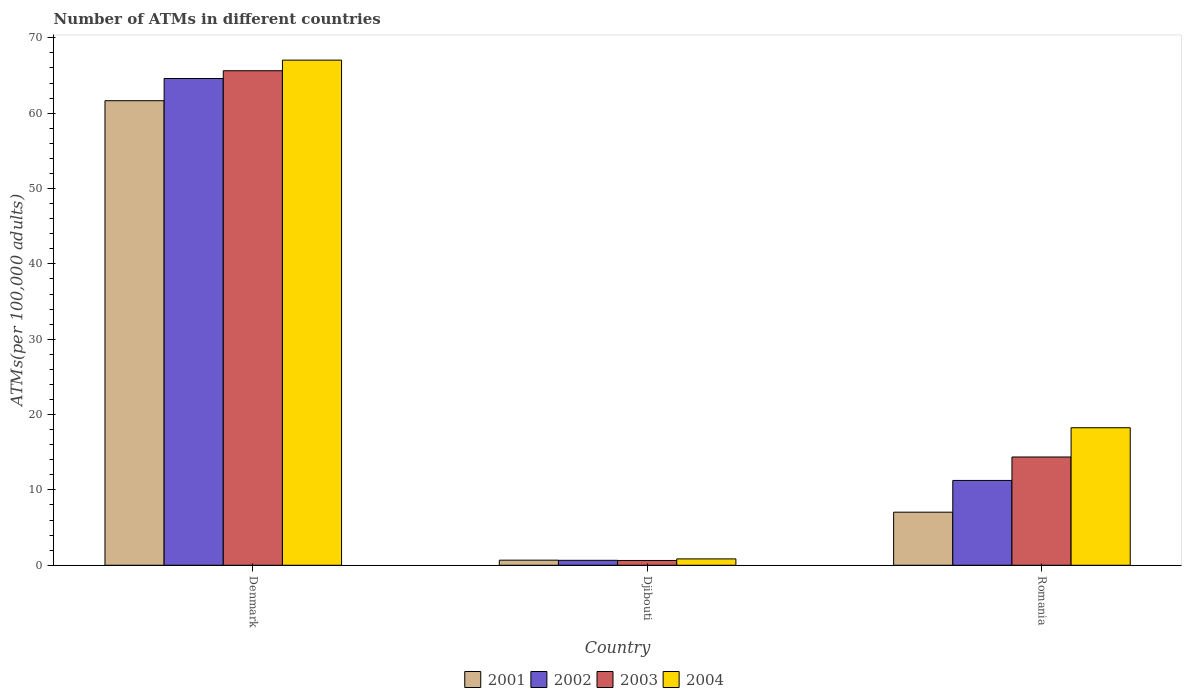How many different coloured bars are there?
Make the answer very short. 4. How many groups of bars are there?
Ensure brevity in your answer.  3. Are the number of bars on each tick of the X-axis equal?
Ensure brevity in your answer.  Yes. How many bars are there on the 2nd tick from the left?
Make the answer very short. 4. How many bars are there on the 1st tick from the right?
Ensure brevity in your answer.  4. What is the label of the 2nd group of bars from the left?
Your answer should be compact. Djibouti. In how many cases, is the number of bars for a given country not equal to the number of legend labels?
Give a very brief answer. 0. What is the number of ATMs in 2001 in Djibouti?
Provide a short and direct response. 0.68. Across all countries, what is the maximum number of ATMs in 2001?
Ensure brevity in your answer.  61.66. Across all countries, what is the minimum number of ATMs in 2002?
Keep it short and to the point. 0.66. In which country was the number of ATMs in 2004 maximum?
Your answer should be compact. Denmark. In which country was the number of ATMs in 2002 minimum?
Your answer should be very brief. Djibouti. What is the total number of ATMs in 2004 in the graph?
Ensure brevity in your answer.  86.14. What is the difference between the number of ATMs in 2002 in Denmark and that in Romania?
Keep it short and to the point. 53.35. What is the difference between the number of ATMs in 2001 in Romania and the number of ATMs in 2003 in Djibouti?
Ensure brevity in your answer.  6.41. What is the average number of ATMs in 2004 per country?
Make the answer very short. 28.71. What is the difference between the number of ATMs of/in 2002 and number of ATMs of/in 2004 in Djibouti?
Make the answer very short. -0.19. In how many countries, is the number of ATMs in 2002 greater than 46?
Keep it short and to the point. 1. What is the ratio of the number of ATMs in 2004 in Djibouti to that in Romania?
Your response must be concise. 0.05. What is the difference between the highest and the second highest number of ATMs in 2003?
Provide a succinct answer. -65. What is the difference between the highest and the lowest number of ATMs in 2003?
Your response must be concise. 65. Is the sum of the number of ATMs in 2003 in Djibouti and Romania greater than the maximum number of ATMs in 2001 across all countries?
Give a very brief answer. No. What does the 1st bar from the left in Denmark represents?
Your answer should be very brief. 2001. How many bars are there?
Provide a short and direct response. 12. How many countries are there in the graph?
Provide a succinct answer. 3. What is the difference between two consecutive major ticks on the Y-axis?
Offer a very short reply. 10. Does the graph contain any zero values?
Provide a succinct answer. No. How many legend labels are there?
Your answer should be compact. 4. How are the legend labels stacked?
Provide a short and direct response. Horizontal. What is the title of the graph?
Your response must be concise. Number of ATMs in different countries. What is the label or title of the X-axis?
Offer a terse response. Country. What is the label or title of the Y-axis?
Offer a terse response. ATMs(per 100,0 adults). What is the ATMs(per 100,000 adults) of 2001 in Denmark?
Provide a short and direct response. 61.66. What is the ATMs(per 100,000 adults) of 2002 in Denmark?
Offer a very short reply. 64.61. What is the ATMs(per 100,000 adults) in 2003 in Denmark?
Give a very brief answer. 65.64. What is the ATMs(per 100,000 adults) of 2004 in Denmark?
Offer a very short reply. 67.04. What is the ATMs(per 100,000 adults) of 2001 in Djibouti?
Provide a short and direct response. 0.68. What is the ATMs(per 100,000 adults) in 2002 in Djibouti?
Make the answer very short. 0.66. What is the ATMs(per 100,000 adults) of 2003 in Djibouti?
Give a very brief answer. 0.64. What is the ATMs(per 100,000 adults) of 2004 in Djibouti?
Your response must be concise. 0.84. What is the ATMs(per 100,000 adults) of 2001 in Romania?
Provide a succinct answer. 7.04. What is the ATMs(per 100,000 adults) in 2002 in Romania?
Keep it short and to the point. 11.26. What is the ATMs(per 100,000 adults) in 2003 in Romania?
Offer a very short reply. 14.37. What is the ATMs(per 100,000 adults) in 2004 in Romania?
Your answer should be very brief. 18.26. Across all countries, what is the maximum ATMs(per 100,000 adults) of 2001?
Offer a terse response. 61.66. Across all countries, what is the maximum ATMs(per 100,000 adults) of 2002?
Give a very brief answer. 64.61. Across all countries, what is the maximum ATMs(per 100,000 adults) in 2003?
Provide a succinct answer. 65.64. Across all countries, what is the maximum ATMs(per 100,000 adults) of 2004?
Ensure brevity in your answer.  67.04. Across all countries, what is the minimum ATMs(per 100,000 adults) in 2001?
Provide a succinct answer. 0.68. Across all countries, what is the minimum ATMs(per 100,000 adults) of 2002?
Provide a succinct answer. 0.66. Across all countries, what is the minimum ATMs(per 100,000 adults) in 2003?
Offer a very short reply. 0.64. Across all countries, what is the minimum ATMs(per 100,000 adults) in 2004?
Offer a very short reply. 0.84. What is the total ATMs(per 100,000 adults) in 2001 in the graph?
Keep it short and to the point. 69.38. What is the total ATMs(per 100,000 adults) in 2002 in the graph?
Your response must be concise. 76.52. What is the total ATMs(per 100,000 adults) in 2003 in the graph?
Offer a terse response. 80.65. What is the total ATMs(per 100,000 adults) of 2004 in the graph?
Your response must be concise. 86.14. What is the difference between the ATMs(per 100,000 adults) of 2001 in Denmark and that in Djibouti?
Your answer should be compact. 60.98. What is the difference between the ATMs(per 100,000 adults) of 2002 in Denmark and that in Djibouti?
Offer a terse response. 63.95. What is the difference between the ATMs(per 100,000 adults) in 2003 in Denmark and that in Djibouti?
Give a very brief answer. 65. What is the difference between the ATMs(per 100,000 adults) in 2004 in Denmark and that in Djibouti?
Provide a short and direct response. 66.2. What is the difference between the ATMs(per 100,000 adults) in 2001 in Denmark and that in Romania?
Provide a succinct answer. 54.61. What is the difference between the ATMs(per 100,000 adults) of 2002 in Denmark and that in Romania?
Ensure brevity in your answer.  53.35. What is the difference between the ATMs(per 100,000 adults) of 2003 in Denmark and that in Romania?
Offer a very short reply. 51.27. What is the difference between the ATMs(per 100,000 adults) in 2004 in Denmark and that in Romania?
Your answer should be very brief. 48.79. What is the difference between the ATMs(per 100,000 adults) of 2001 in Djibouti and that in Romania?
Ensure brevity in your answer.  -6.37. What is the difference between the ATMs(per 100,000 adults) in 2002 in Djibouti and that in Romania?
Provide a succinct answer. -10.6. What is the difference between the ATMs(per 100,000 adults) of 2003 in Djibouti and that in Romania?
Provide a succinct answer. -13.73. What is the difference between the ATMs(per 100,000 adults) in 2004 in Djibouti and that in Romania?
Offer a terse response. -17.41. What is the difference between the ATMs(per 100,000 adults) in 2001 in Denmark and the ATMs(per 100,000 adults) in 2002 in Djibouti?
Your answer should be compact. 61. What is the difference between the ATMs(per 100,000 adults) of 2001 in Denmark and the ATMs(per 100,000 adults) of 2003 in Djibouti?
Keep it short and to the point. 61.02. What is the difference between the ATMs(per 100,000 adults) of 2001 in Denmark and the ATMs(per 100,000 adults) of 2004 in Djibouti?
Ensure brevity in your answer.  60.81. What is the difference between the ATMs(per 100,000 adults) of 2002 in Denmark and the ATMs(per 100,000 adults) of 2003 in Djibouti?
Keep it short and to the point. 63.97. What is the difference between the ATMs(per 100,000 adults) in 2002 in Denmark and the ATMs(per 100,000 adults) in 2004 in Djibouti?
Give a very brief answer. 63.76. What is the difference between the ATMs(per 100,000 adults) of 2003 in Denmark and the ATMs(per 100,000 adults) of 2004 in Djibouti?
Your answer should be very brief. 64.79. What is the difference between the ATMs(per 100,000 adults) of 2001 in Denmark and the ATMs(per 100,000 adults) of 2002 in Romania?
Make the answer very short. 50.4. What is the difference between the ATMs(per 100,000 adults) of 2001 in Denmark and the ATMs(per 100,000 adults) of 2003 in Romania?
Offer a very short reply. 47.29. What is the difference between the ATMs(per 100,000 adults) of 2001 in Denmark and the ATMs(per 100,000 adults) of 2004 in Romania?
Your response must be concise. 43.4. What is the difference between the ATMs(per 100,000 adults) of 2002 in Denmark and the ATMs(per 100,000 adults) of 2003 in Romania?
Ensure brevity in your answer.  50.24. What is the difference between the ATMs(per 100,000 adults) in 2002 in Denmark and the ATMs(per 100,000 adults) in 2004 in Romania?
Offer a very short reply. 46.35. What is the difference between the ATMs(per 100,000 adults) of 2003 in Denmark and the ATMs(per 100,000 adults) of 2004 in Romania?
Offer a terse response. 47.38. What is the difference between the ATMs(per 100,000 adults) of 2001 in Djibouti and the ATMs(per 100,000 adults) of 2002 in Romania?
Ensure brevity in your answer.  -10.58. What is the difference between the ATMs(per 100,000 adults) in 2001 in Djibouti and the ATMs(per 100,000 adults) in 2003 in Romania?
Make the answer very short. -13.69. What is the difference between the ATMs(per 100,000 adults) in 2001 in Djibouti and the ATMs(per 100,000 adults) in 2004 in Romania?
Make the answer very short. -17.58. What is the difference between the ATMs(per 100,000 adults) of 2002 in Djibouti and the ATMs(per 100,000 adults) of 2003 in Romania?
Your response must be concise. -13.71. What is the difference between the ATMs(per 100,000 adults) of 2002 in Djibouti and the ATMs(per 100,000 adults) of 2004 in Romania?
Give a very brief answer. -17.6. What is the difference between the ATMs(per 100,000 adults) of 2003 in Djibouti and the ATMs(per 100,000 adults) of 2004 in Romania?
Make the answer very short. -17.62. What is the average ATMs(per 100,000 adults) of 2001 per country?
Keep it short and to the point. 23.13. What is the average ATMs(per 100,000 adults) in 2002 per country?
Provide a succinct answer. 25.51. What is the average ATMs(per 100,000 adults) in 2003 per country?
Offer a very short reply. 26.88. What is the average ATMs(per 100,000 adults) of 2004 per country?
Offer a terse response. 28.71. What is the difference between the ATMs(per 100,000 adults) in 2001 and ATMs(per 100,000 adults) in 2002 in Denmark?
Make the answer very short. -2.95. What is the difference between the ATMs(per 100,000 adults) in 2001 and ATMs(per 100,000 adults) in 2003 in Denmark?
Your answer should be compact. -3.98. What is the difference between the ATMs(per 100,000 adults) of 2001 and ATMs(per 100,000 adults) of 2004 in Denmark?
Keep it short and to the point. -5.39. What is the difference between the ATMs(per 100,000 adults) of 2002 and ATMs(per 100,000 adults) of 2003 in Denmark?
Your response must be concise. -1.03. What is the difference between the ATMs(per 100,000 adults) of 2002 and ATMs(per 100,000 adults) of 2004 in Denmark?
Offer a very short reply. -2.44. What is the difference between the ATMs(per 100,000 adults) of 2003 and ATMs(per 100,000 adults) of 2004 in Denmark?
Offer a very short reply. -1.41. What is the difference between the ATMs(per 100,000 adults) of 2001 and ATMs(per 100,000 adults) of 2002 in Djibouti?
Your answer should be compact. 0.02. What is the difference between the ATMs(per 100,000 adults) of 2001 and ATMs(per 100,000 adults) of 2003 in Djibouti?
Provide a succinct answer. 0.04. What is the difference between the ATMs(per 100,000 adults) in 2001 and ATMs(per 100,000 adults) in 2004 in Djibouti?
Keep it short and to the point. -0.17. What is the difference between the ATMs(per 100,000 adults) of 2002 and ATMs(per 100,000 adults) of 2003 in Djibouti?
Keep it short and to the point. 0.02. What is the difference between the ATMs(per 100,000 adults) of 2002 and ATMs(per 100,000 adults) of 2004 in Djibouti?
Your response must be concise. -0.19. What is the difference between the ATMs(per 100,000 adults) of 2003 and ATMs(per 100,000 adults) of 2004 in Djibouti?
Provide a succinct answer. -0.21. What is the difference between the ATMs(per 100,000 adults) of 2001 and ATMs(per 100,000 adults) of 2002 in Romania?
Ensure brevity in your answer.  -4.21. What is the difference between the ATMs(per 100,000 adults) in 2001 and ATMs(per 100,000 adults) in 2003 in Romania?
Offer a very short reply. -7.32. What is the difference between the ATMs(per 100,000 adults) of 2001 and ATMs(per 100,000 adults) of 2004 in Romania?
Your answer should be compact. -11.21. What is the difference between the ATMs(per 100,000 adults) in 2002 and ATMs(per 100,000 adults) in 2003 in Romania?
Provide a short and direct response. -3.11. What is the difference between the ATMs(per 100,000 adults) of 2002 and ATMs(per 100,000 adults) of 2004 in Romania?
Offer a very short reply. -7. What is the difference between the ATMs(per 100,000 adults) in 2003 and ATMs(per 100,000 adults) in 2004 in Romania?
Ensure brevity in your answer.  -3.89. What is the ratio of the ATMs(per 100,000 adults) in 2001 in Denmark to that in Djibouti?
Give a very brief answer. 91.18. What is the ratio of the ATMs(per 100,000 adults) in 2002 in Denmark to that in Djibouti?
Offer a very short reply. 98.45. What is the ratio of the ATMs(per 100,000 adults) of 2003 in Denmark to that in Djibouti?
Keep it short and to the point. 102.88. What is the ratio of the ATMs(per 100,000 adults) of 2004 in Denmark to that in Djibouti?
Give a very brief answer. 79.46. What is the ratio of the ATMs(per 100,000 adults) of 2001 in Denmark to that in Romania?
Offer a very short reply. 8.75. What is the ratio of the ATMs(per 100,000 adults) of 2002 in Denmark to that in Romania?
Your answer should be compact. 5.74. What is the ratio of the ATMs(per 100,000 adults) of 2003 in Denmark to that in Romania?
Give a very brief answer. 4.57. What is the ratio of the ATMs(per 100,000 adults) of 2004 in Denmark to that in Romania?
Ensure brevity in your answer.  3.67. What is the ratio of the ATMs(per 100,000 adults) of 2001 in Djibouti to that in Romania?
Provide a succinct answer. 0.1. What is the ratio of the ATMs(per 100,000 adults) in 2002 in Djibouti to that in Romania?
Provide a succinct answer. 0.06. What is the ratio of the ATMs(per 100,000 adults) of 2003 in Djibouti to that in Romania?
Make the answer very short. 0.04. What is the ratio of the ATMs(per 100,000 adults) of 2004 in Djibouti to that in Romania?
Keep it short and to the point. 0.05. What is the difference between the highest and the second highest ATMs(per 100,000 adults) in 2001?
Provide a succinct answer. 54.61. What is the difference between the highest and the second highest ATMs(per 100,000 adults) in 2002?
Your response must be concise. 53.35. What is the difference between the highest and the second highest ATMs(per 100,000 adults) of 2003?
Give a very brief answer. 51.27. What is the difference between the highest and the second highest ATMs(per 100,000 adults) in 2004?
Provide a short and direct response. 48.79. What is the difference between the highest and the lowest ATMs(per 100,000 adults) in 2001?
Make the answer very short. 60.98. What is the difference between the highest and the lowest ATMs(per 100,000 adults) in 2002?
Keep it short and to the point. 63.95. What is the difference between the highest and the lowest ATMs(per 100,000 adults) of 2003?
Your answer should be very brief. 65. What is the difference between the highest and the lowest ATMs(per 100,000 adults) of 2004?
Your response must be concise. 66.2. 